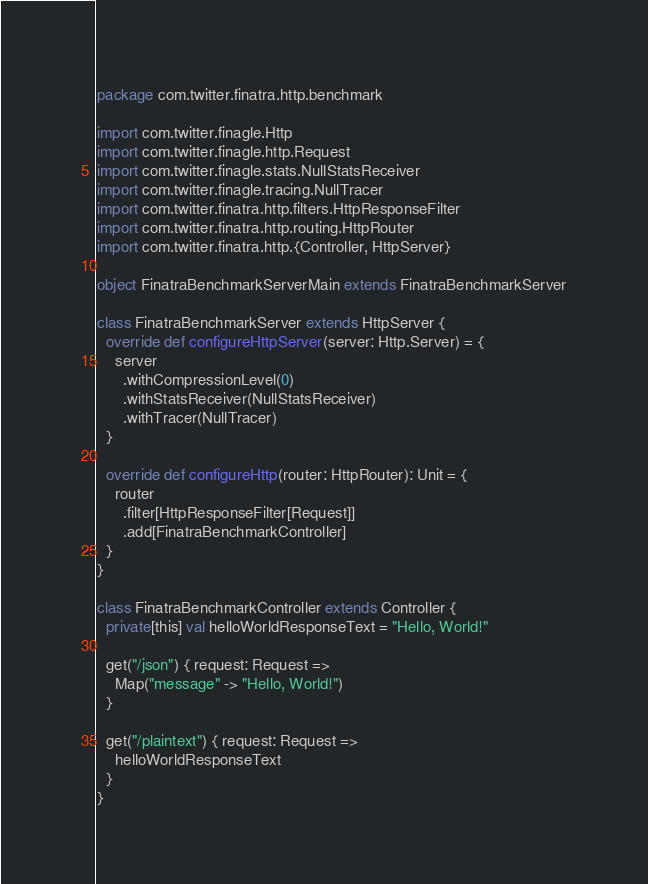Convert code to text. <code><loc_0><loc_0><loc_500><loc_500><_Scala_>package com.twitter.finatra.http.benchmark

import com.twitter.finagle.Http
import com.twitter.finagle.http.Request
import com.twitter.finagle.stats.NullStatsReceiver
import com.twitter.finagle.tracing.NullTracer
import com.twitter.finatra.http.filters.HttpResponseFilter
import com.twitter.finatra.http.routing.HttpRouter
import com.twitter.finatra.http.{Controller, HttpServer}

object FinatraBenchmarkServerMain extends FinatraBenchmarkServer

class FinatraBenchmarkServer extends HttpServer {
  override def configureHttpServer(server: Http.Server) = {
    server
      .withCompressionLevel(0)
      .withStatsReceiver(NullStatsReceiver)
      .withTracer(NullTracer)
  }

  override def configureHttp(router: HttpRouter): Unit = {
    router
      .filter[HttpResponseFilter[Request]]
      .add[FinatraBenchmarkController]
  }
}

class FinatraBenchmarkController extends Controller {
  private[this] val helloWorldResponseText = "Hello, World!"

  get("/json") { request: Request =>
    Map("message" -> "Hello, World!")
  }

  get("/plaintext") { request: Request =>
    helloWorldResponseText
  }
}</code> 